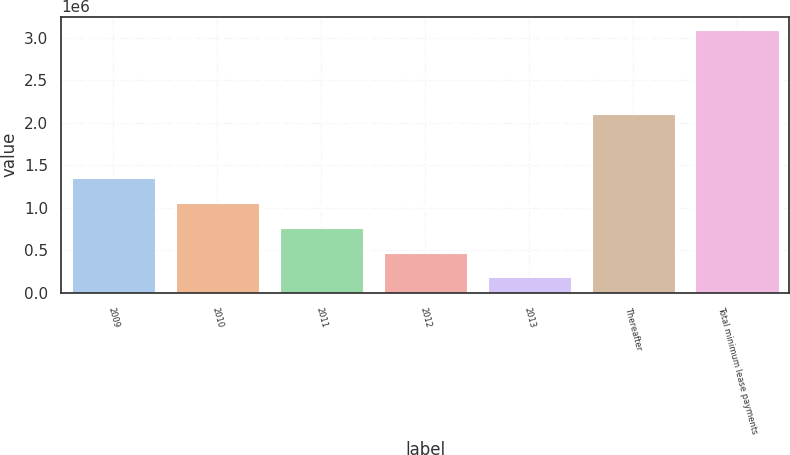Convert chart. <chart><loc_0><loc_0><loc_500><loc_500><bar_chart><fcel>2009<fcel>2010<fcel>2011<fcel>2012<fcel>2013<fcel>Thereafter<fcel>Total minimum lease payments<nl><fcel>1.34663e+06<fcel>1.05524e+06<fcel>763856<fcel>472468<fcel>181080<fcel>2.10909e+06<fcel>3.09496e+06<nl></chart> 